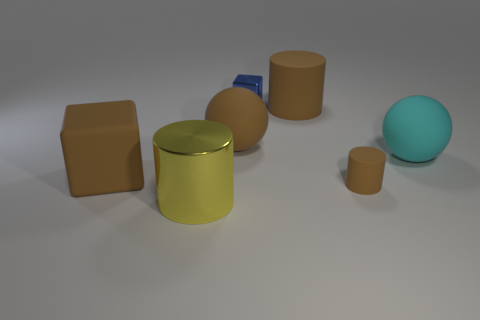What textures are visible in the objects within the image? The objects in the image exhibit a variety of textures. The brown cube and the small cylinders appear to have a matte finish, whereas the large yellow cylinder has a reflective surface. The sphere has a smooth texture, and the small blue object seems to have a slightly rougher surface compared to the other objects. 